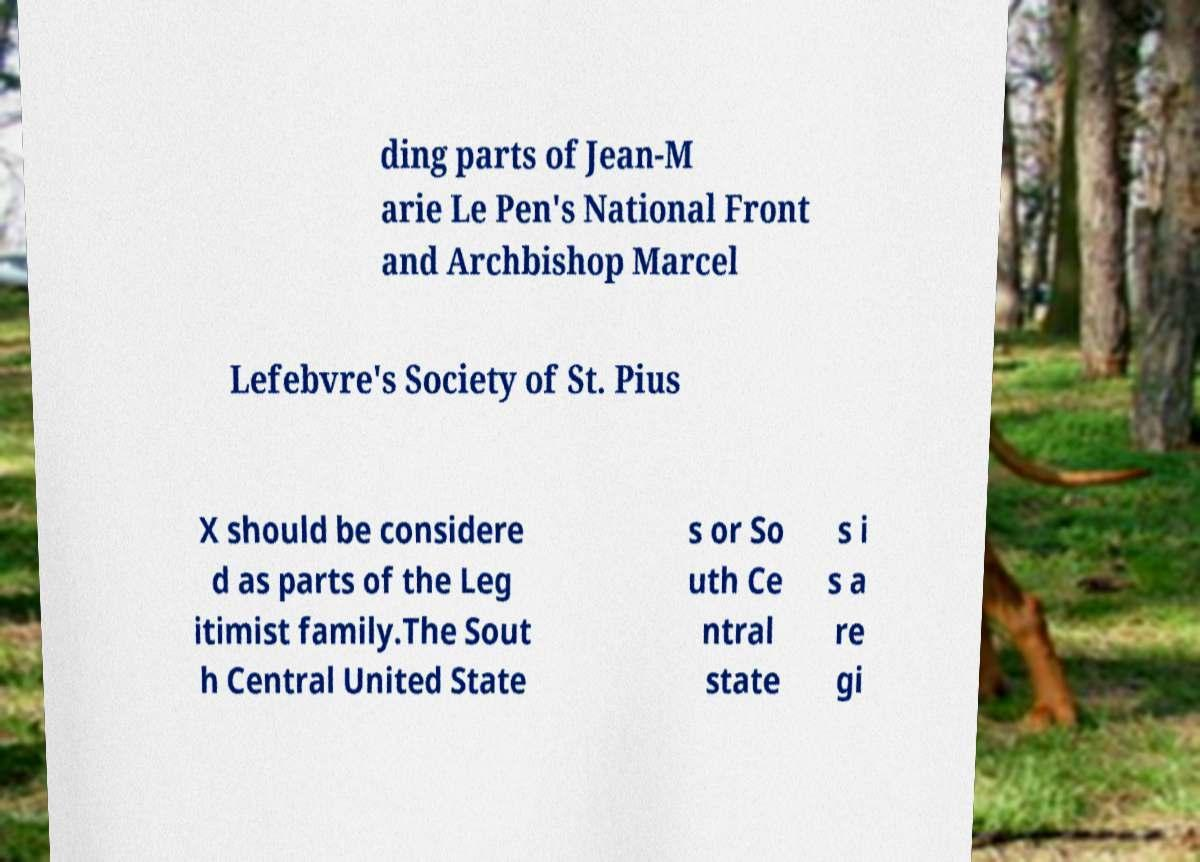For documentation purposes, I need the text within this image transcribed. Could you provide that? ding parts of Jean-M arie Le Pen's National Front and Archbishop Marcel Lefebvre's Society of St. Pius X should be considere d as parts of the Leg itimist family.The Sout h Central United State s or So uth Ce ntral state s i s a re gi 